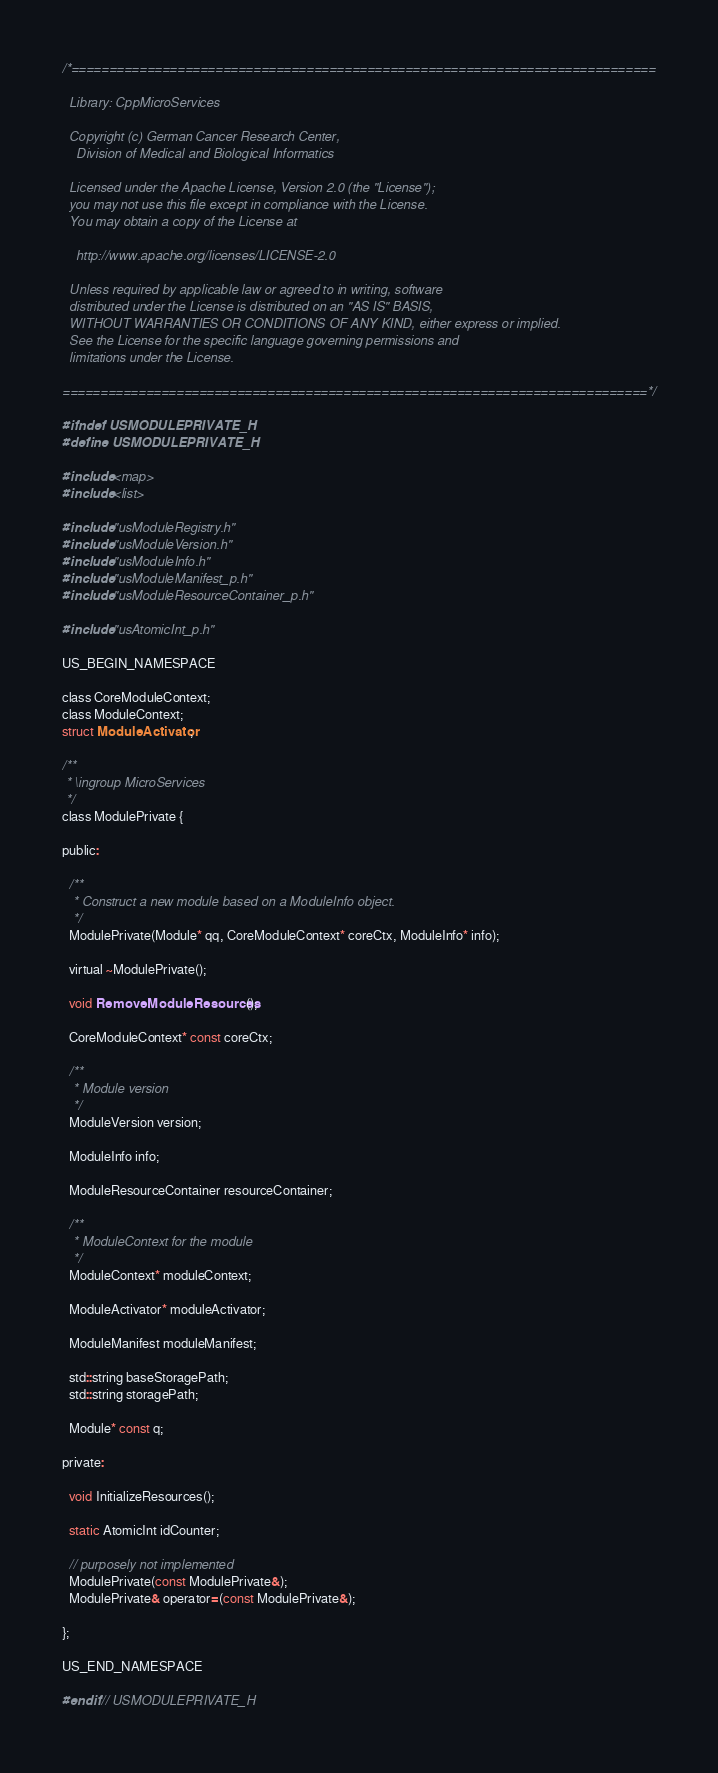<code> <loc_0><loc_0><loc_500><loc_500><_C_>/*=============================================================================

  Library: CppMicroServices

  Copyright (c) German Cancer Research Center,
    Division of Medical and Biological Informatics

  Licensed under the Apache License, Version 2.0 (the "License");
  you may not use this file except in compliance with the License.
  You may obtain a copy of the License at

    http://www.apache.org/licenses/LICENSE-2.0

  Unless required by applicable law or agreed to in writing, software
  distributed under the License is distributed on an "AS IS" BASIS,
  WITHOUT WARRANTIES OR CONDITIONS OF ANY KIND, either express or implied.
  See the License for the specific language governing permissions and
  limitations under the License.

=============================================================================*/

#ifndef USMODULEPRIVATE_H
#define USMODULEPRIVATE_H

#include <map>
#include <list>

#include "usModuleRegistry.h"
#include "usModuleVersion.h"
#include "usModuleInfo.h"
#include "usModuleManifest_p.h"
#include "usModuleResourceContainer_p.h"

#include "usAtomicInt_p.h"

US_BEGIN_NAMESPACE

class CoreModuleContext;
class ModuleContext;
struct ModuleActivator;

/**
 * \ingroup MicroServices
 */
class ModulePrivate {

public:

  /**
   * Construct a new module based on a ModuleInfo object.
   */
  ModulePrivate(Module* qq, CoreModuleContext* coreCtx, ModuleInfo* info);

  virtual ~ModulePrivate();

  void RemoveModuleResources();

  CoreModuleContext* const coreCtx;

  /**
   * Module version
   */
  ModuleVersion version;

  ModuleInfo info;

  ModuleResourceContainer resourceContainer;

  /**
   * ModuleContext for the module
   */
  ModuleContext* moduleContext;

  ModuleActivator* moduleActivator;

  ModuleManifest moduleManifest;

  std::string baseStoragePath;
  std::string storagePath;

  Module* const q;

private:

  void InitializeResources();

  static AtomicInt idCounter;

  // purposely not implemented
  ModulePrivate(const ModulePrivate&);
  ModulePrivate& operator=(const ModulePrivate&);

};

US_END_NAMESPACE

#endif // USMODULEPRIVATE_H
</code> 